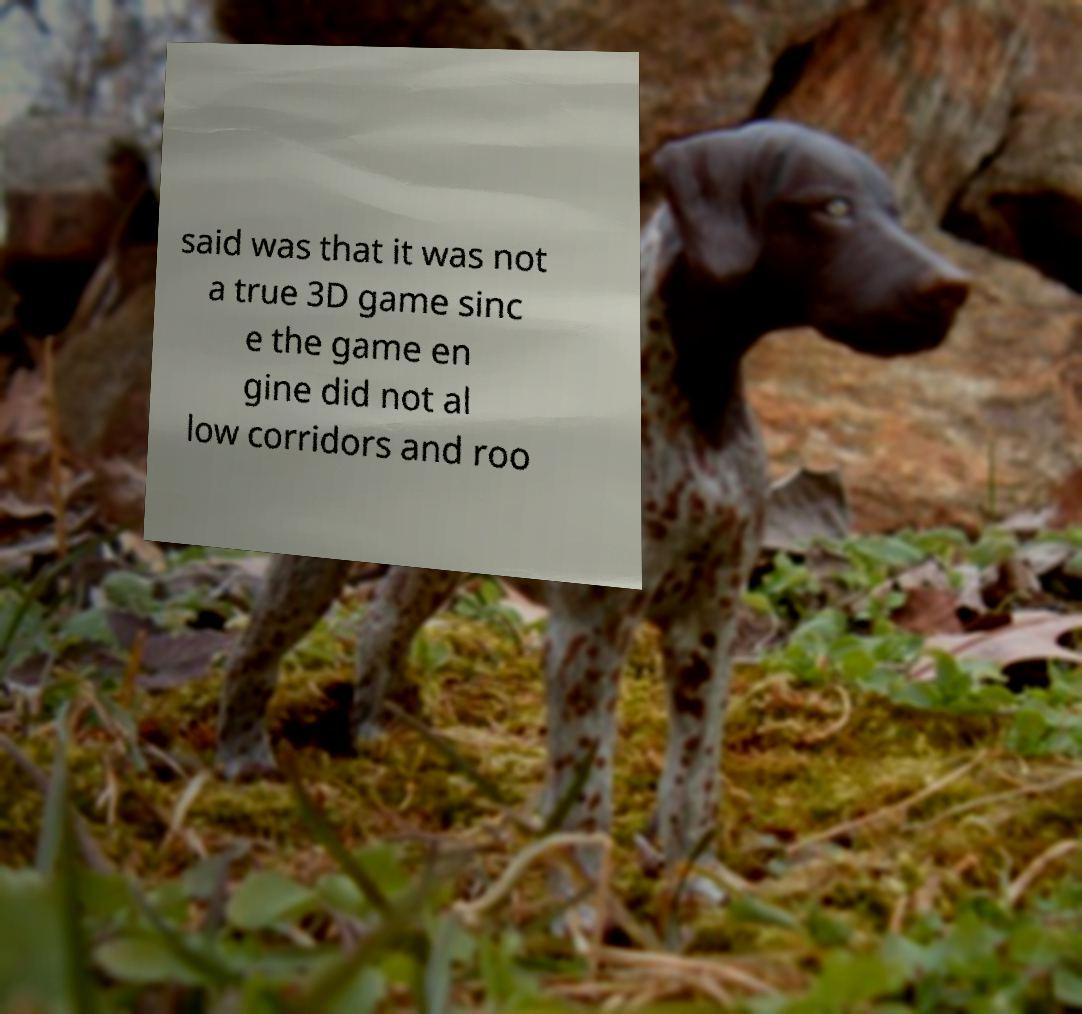Could you extract and type out the text from this image? said was that it was not a true 3D game sinc e the game en gine did not al low corridors and roo 